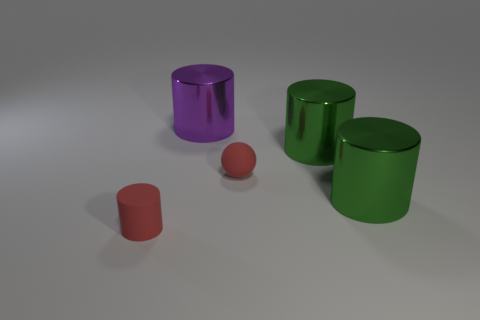Are there any red matte things that have the same shape as the purple metallic object?
Provide a succinct answer. Yes. What is the material of the purple thing?
Your response must be concise. Metal. There is a metal cylinder that is behind the tiny red sphere and in front of the purple metallic object; how big is it?
Your answer should be very brief. Large. What material is the small thing that is the same color as the small rubber cylinder?
Offer a very short reply. Rubber. How many small matte balls are there?
Your answer should be very brief. 1. Are there fewer red cylinders than big metallic things?
Give a very brief answer. Yes. What is the material of the object that is the same size as the red rubber cylinder?
Make the answer very short. Rubber. How many objects are blocks or tiny rubber objects?
Give a very brief answer. 2. What number of cylinders are both in front of the purple metal cylinder and behind the red cylinder?
Provide a succinct answer. 2. Are there fewer rubber cylinders in front of the red ball than small cyan matte cylinders?
Your answer should be compact. No. 